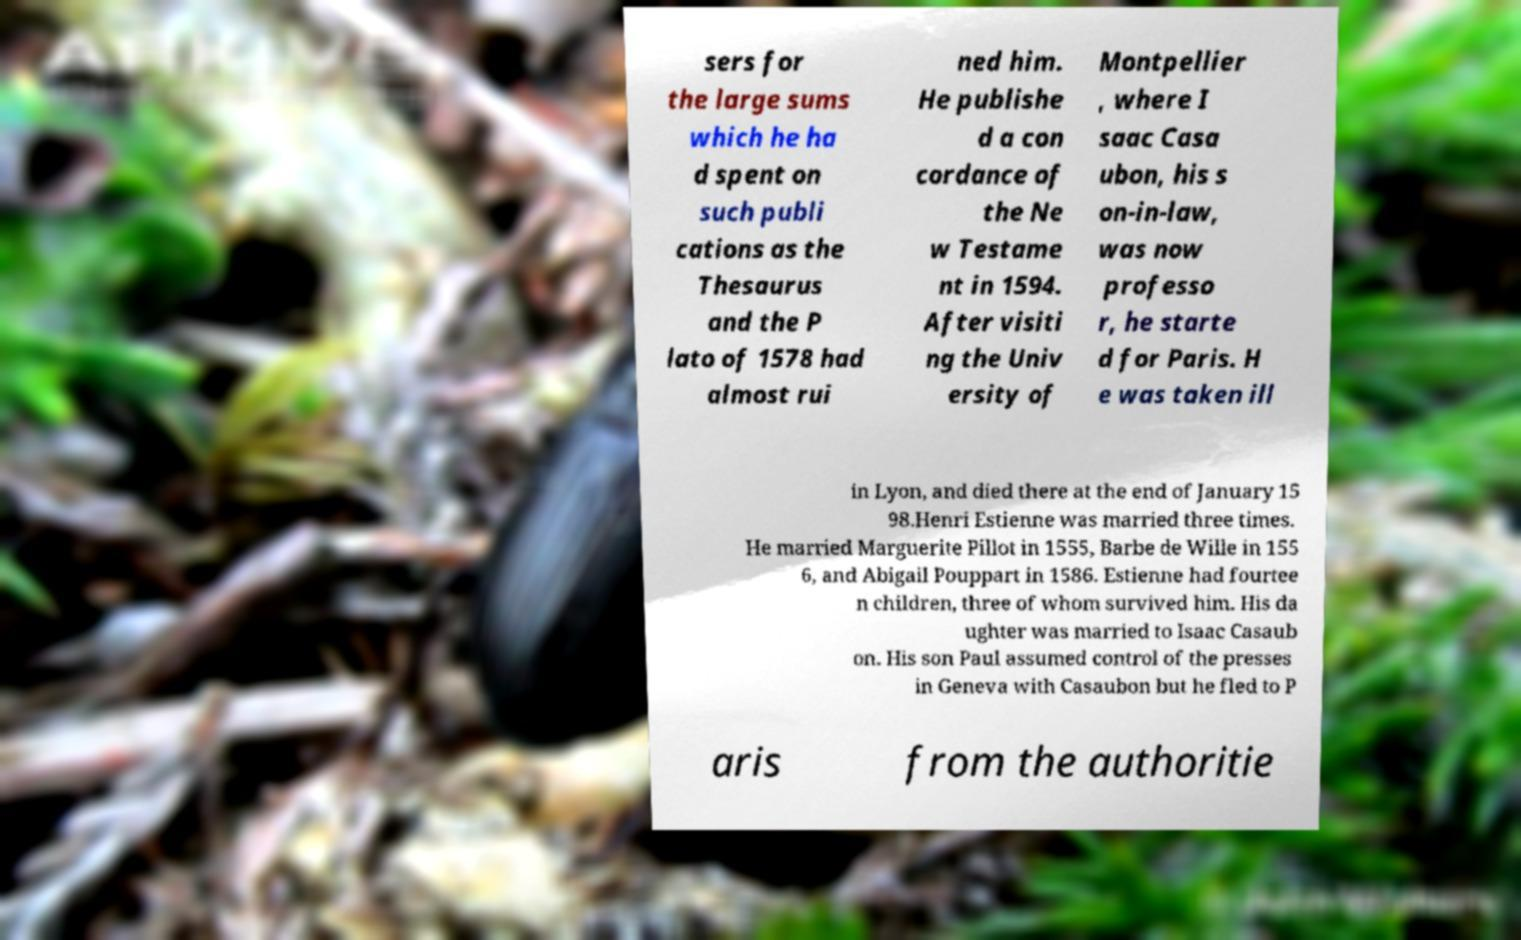Could you extract and type out the text from this image? sers for the large sums which he ha d spent on such publi cations as the Thesaurus and the P lato of 1578 had almost rui ned him. He publishe d a con cordance of the Ne w Testame nt in 1594. After visiti ng the Univ ersity of Montpellier , where I saac Casa ubon, his s on-in-law, was now professo r, he starte d for Paris. H e was taken ill in Lyon, and died there at the end of January 15 98.Henri Estienne was married three times. He married Marguerite Pillot in 1555, Barbe de Wille in 155 6, and Abigail Pouppart in 1586. Estienne had fourtee n children, three of whom survived him. His da ughter was married to Isaac Casaub on. His son Paul assumed control of the presses in Geneva with Casaubon but he fled to P aris from the authoritie 